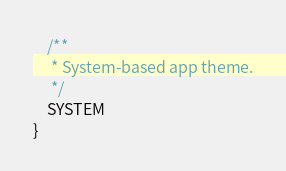<code> <loc_0><loc_0><loc_500><loc_500><_Kotlin_>    /**
     * System-based app theme.
     */
    SYSTEM
}
</code> 